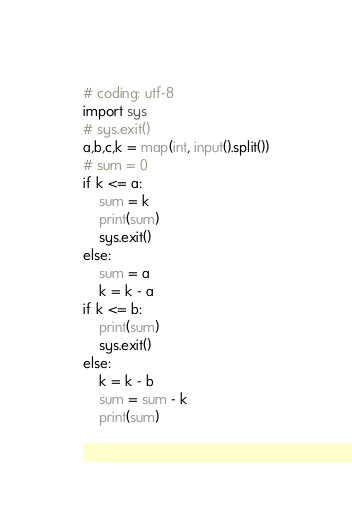Convert code to text. <code><loc_0><loc_0><loc_500><loc_500><_Python_># coding: utf-8
import sys
# sys.exit()
a,b,c,k = map(int, input().split())
# sum = 0
if k <= a:
    sum = k
    print(sum)
    sys.exit()
else:
    sum = a
    k = k - a
if k <= b:
    print(sum)
    sys.exit()
else:
    k = k - b
    sum = sum - k
    print(sum)
</code> 